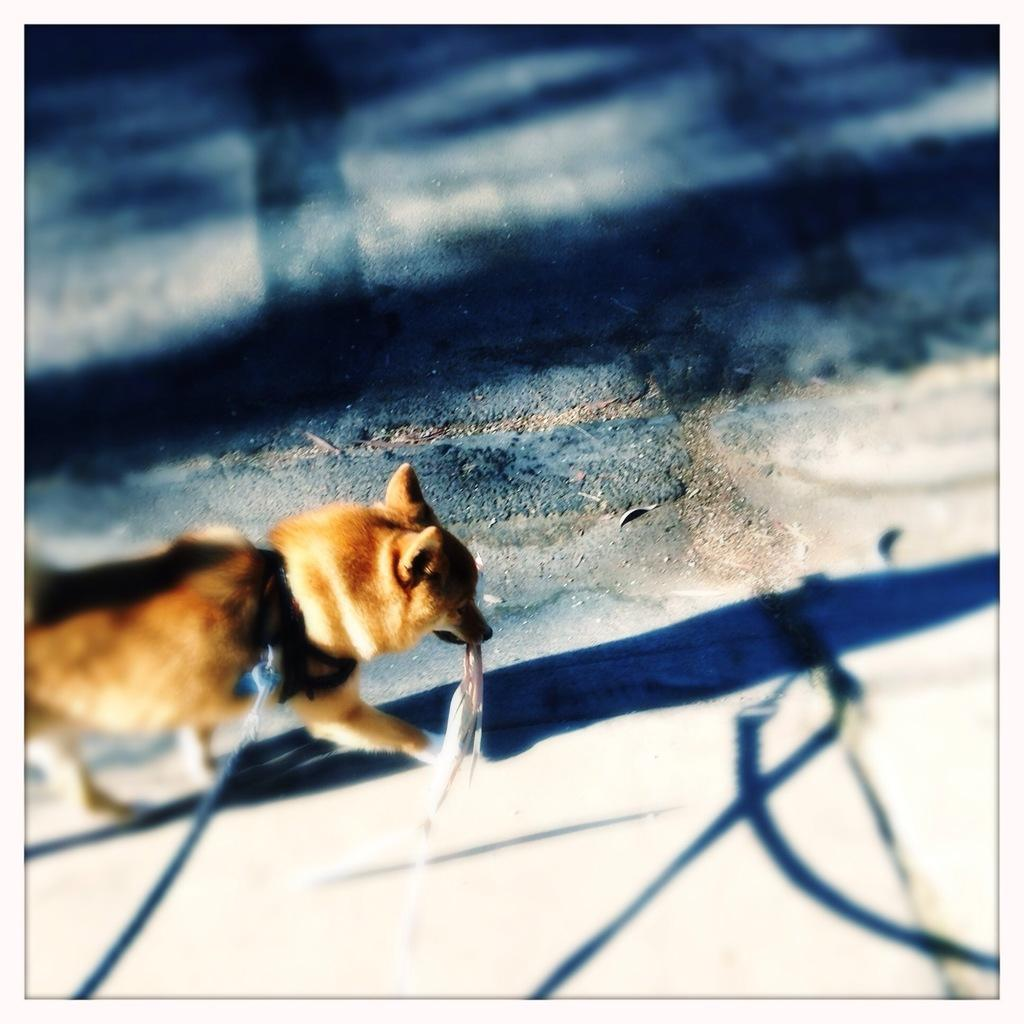What animal can be seen in the image? There is a dog in the image. Where is the dog located? The dog is on the road. What is the dog holding in the image? The dog is holding a cloth. Is the dog attached to anything in the image? Yes, there is a chain attached to the dog. What can be observed on the ground in the image? There are reflections visible on the ground in the image. What type of tray is the dog carrying in the image? There is no tray present in the image; the dog is holding a cloth. 